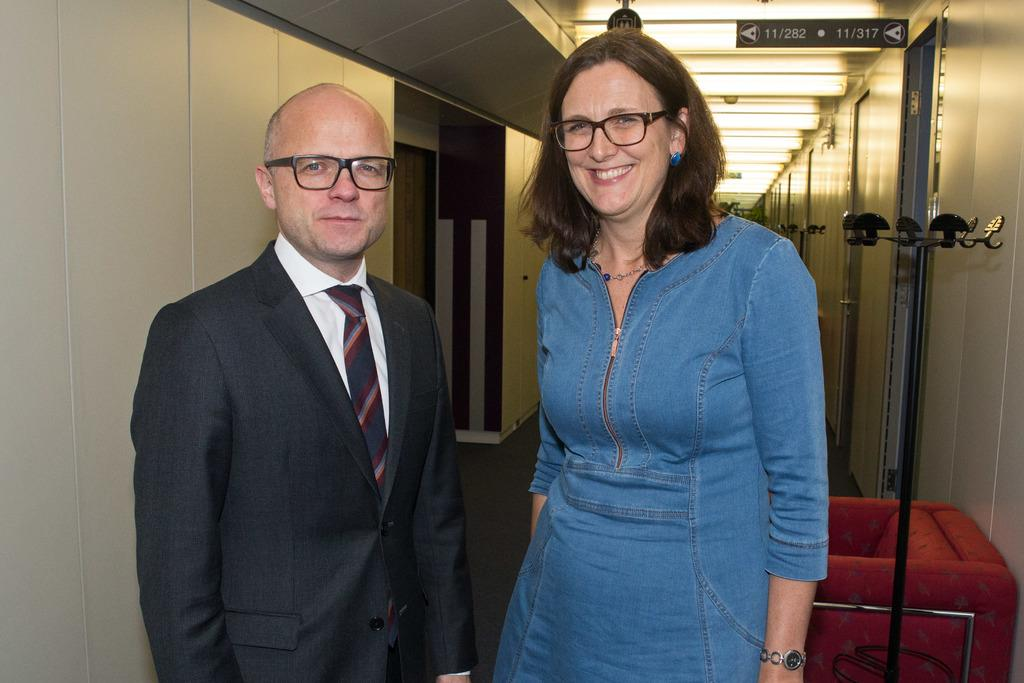How many people are present in the image? There are two people in the image, a man and a woman. What are the people wearing in the image? Both the man and the woman are wearing spectacles in the image. What can be seen in the background of the image? There are wooden walls and lights visible in the background of the image. What type of wound can be seen on the woman's arm in the image? There is no wound visible on the woman's arm in the image. What word is written on the wooden wall in the image? There are no words written on the wooden wall in the image. 